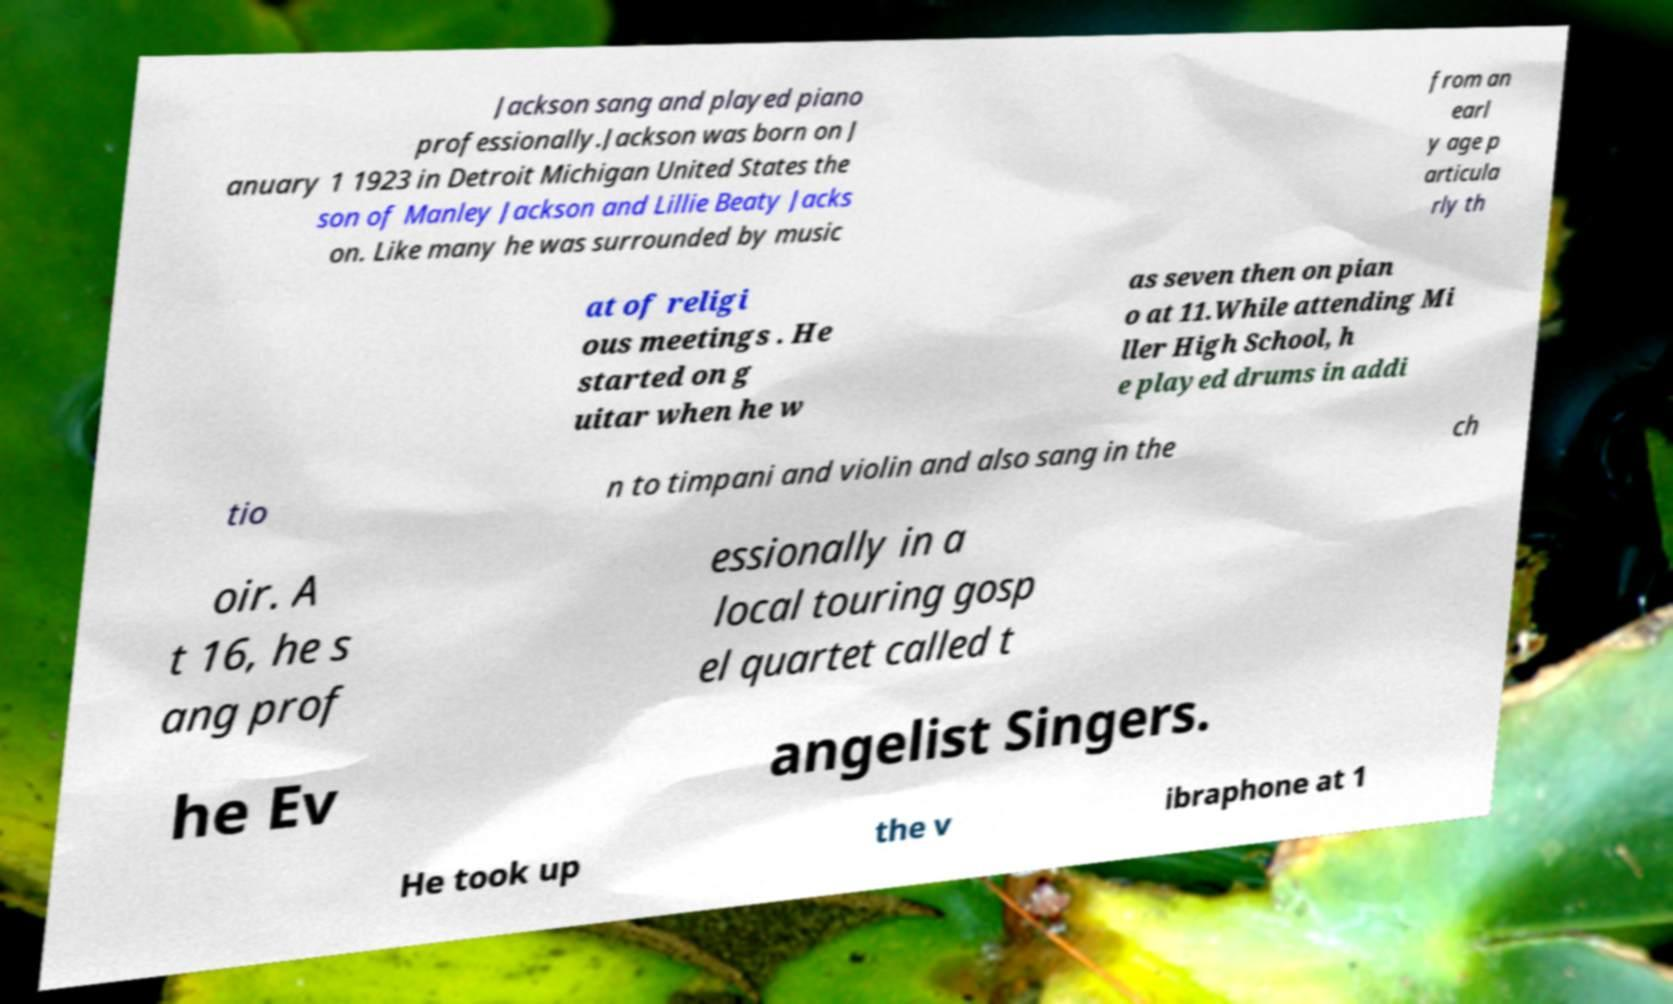Please identify and transcribe the text found in this image. Jackson sang and played piano professionally.Jackson was born on J anuary 1 1923 in Detroit Michigan United States the son of Manley Jackson and Lillie Beaty Jacks on. Like many he was surrounded by music from an earl y age p articula rly th at of religi ous meetings . He started on g uitar when he w as seven then on pian o at 11.While attending Mi ller High School, h e played drums in addi tio n to timpani and violin and also sang in the ch oir. A t 16, he s ang prof essionally in a local touring gosp el quartet called t he Ev angelist Singers. He took up the v ibraphone at 1 